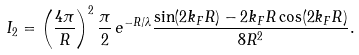Convert formula to latex. <formula><loc_0><loc_0><loc_500><loc_500>I _ { 2 } = \left ( \frac { 4 \pi } { R } \right ) ^ { 2 } \frac { \pi } { 2 } \, e ^ { - R / \lambda } \frac { \sin ( 2 k _ { F } R ) - 2 k _ { F } R \cos ( 2 k _ { F } R ) } { 8 R ^ { 2 } } .</formula> 